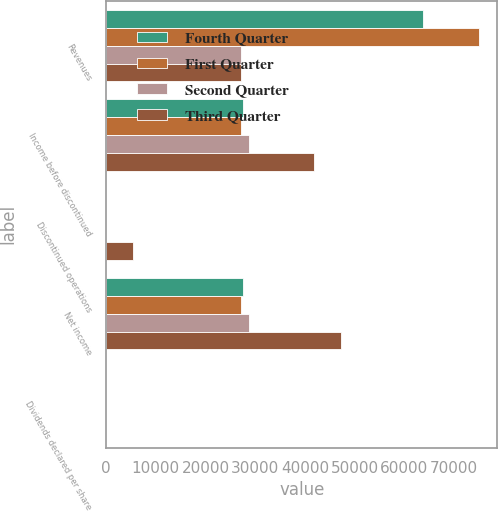Convert chart. <chart><loc_0><loc_0><loc_500><loc_500><stacked_bar_chart><ecel><fcel>Revenues<fcel>Income before discontinued<fcel>Discontinued operations<fcel>Net income<fcel>Dividends declared per share<nl><fcel>Fourth Quarter<fcel>63800<fcel>27612<fcel>39<fcel>27573<fcel>0.36<nl><fcel>First Quarter<fcel>74952<fcel>27108<fcel>40<fcel>27068<fcel>0.36<nl><fcel>Second Quarter<fcel>27088<fcel>28719<fcel>2<fcel>28721<fcel>0.36<nl><fcel>Third Quarter<fcel>27088<fcel>41808<fcel>5413<fcel>47221<fcel>0.36<nl></chart> 